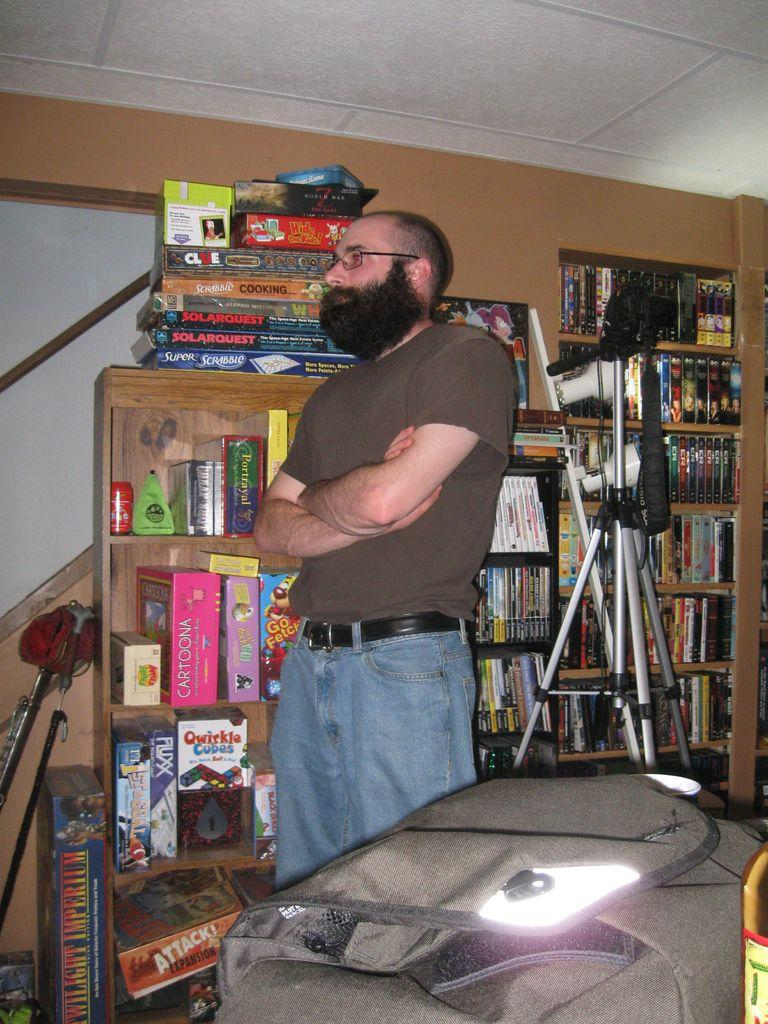<image>
Give a short and clear explanation of the subsequent image. a man standing in front of a shelf of games with one of them labeled as 'cartoona' 